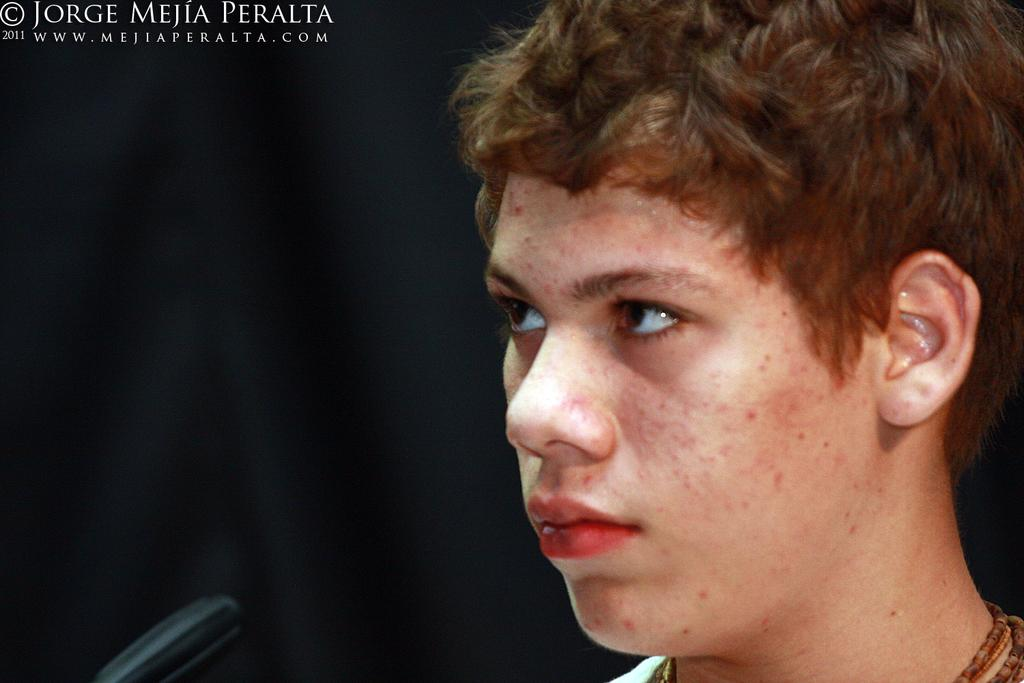What can be seen on the right side of the image? There is a person on the right side of the image. What color is the background of the image? The background of the image is black. What is located at the top of the image? There is text at the top of the image. What is present at the bottom of the image? There is an object at the bottom of the image. How does the person in the image help the bucket on the edge? There is no bucket or edge present in the image, and therefore no such interaction can be observed. 